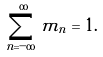<formula> <loc_0><loc_0><loc_500><loc_500>\sum _ { n = - \infty } ^ { \infty } m _ { n } = 1 .</formula> 